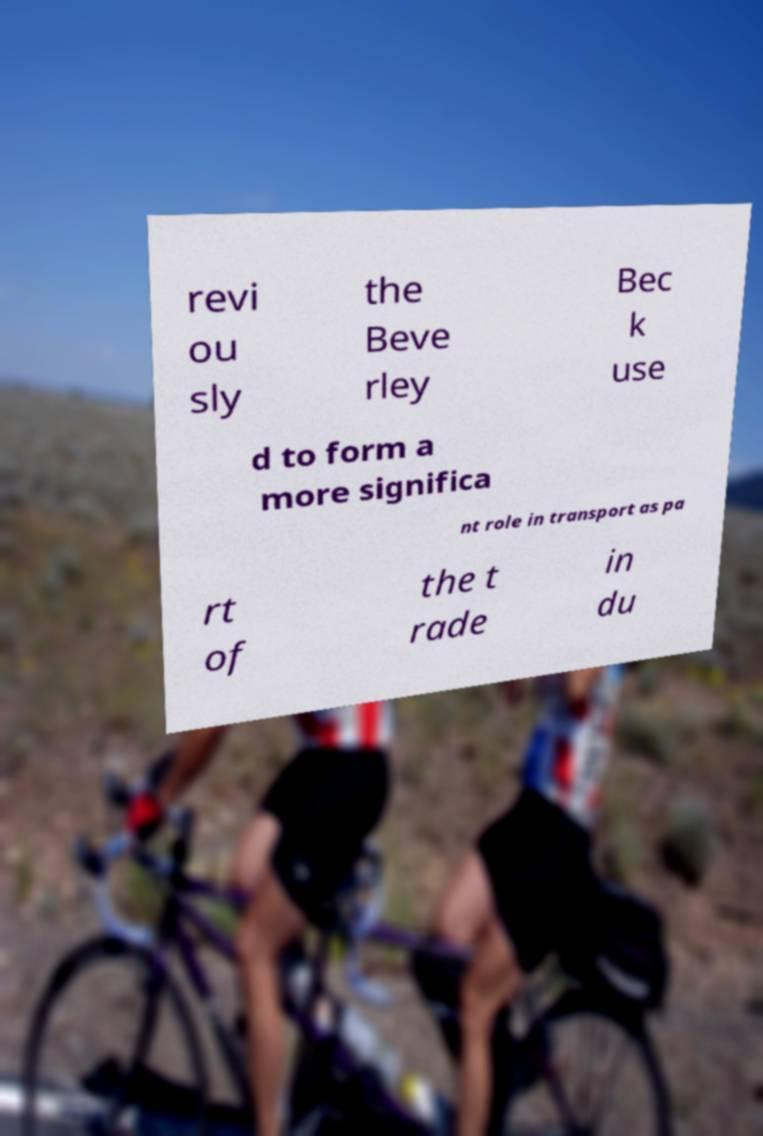Please read and relay the text visible in this image. What does it say? revi ou sly the Beve rley Bec k use d to form a more significa nt role in transport as pa rt of the t rade in du 